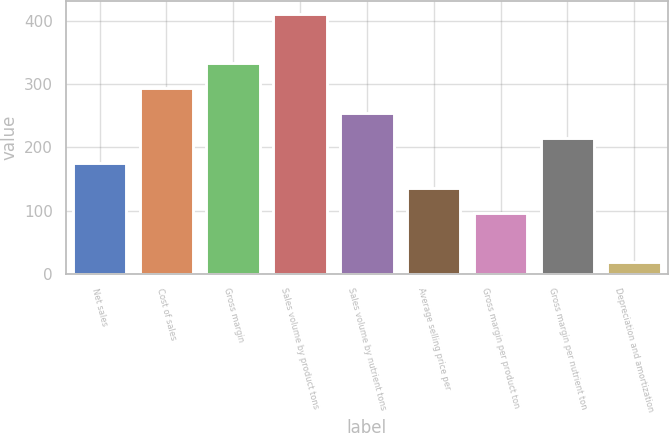<chart> <loc_0><loc_0><loc_500><loc_500><bar_chart><fcel>Net sales<fcel>Cost of sales<fcel>Gross margin<fcel>Sales volume by product tons<fcel>Sales volume by nutrient tons<fcel>Average selling price per<fcel>Gross margin per product ton<fcel>Gross margin per nutrient ton<fcel>Depreciation and amortization<nl><fcel>175.6<fcel>293.8<fcel>333.2<fcel>412<fcel>254.4<fcel>136.2<fcel>96.8<fcel>215<fcel>18<nl></chart> 